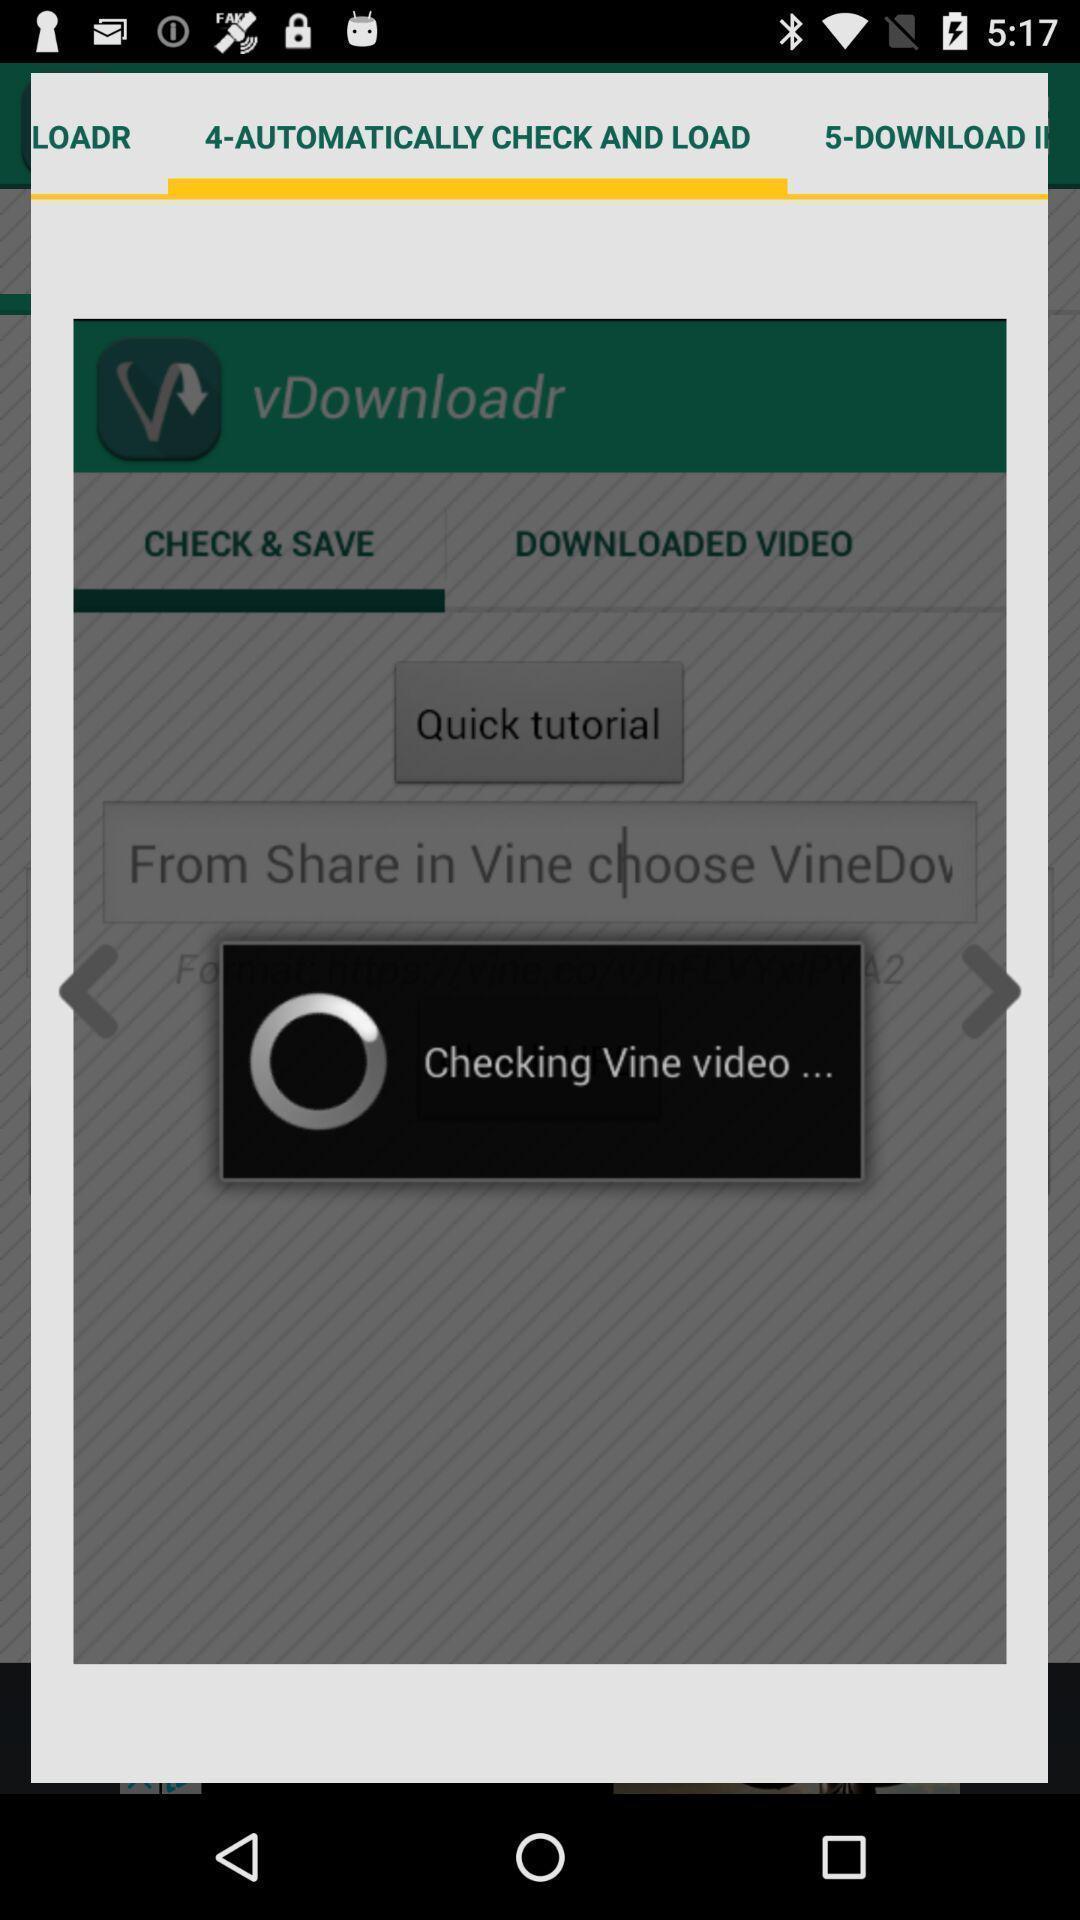Explain the elements present in this screenshot. Video loading page. 